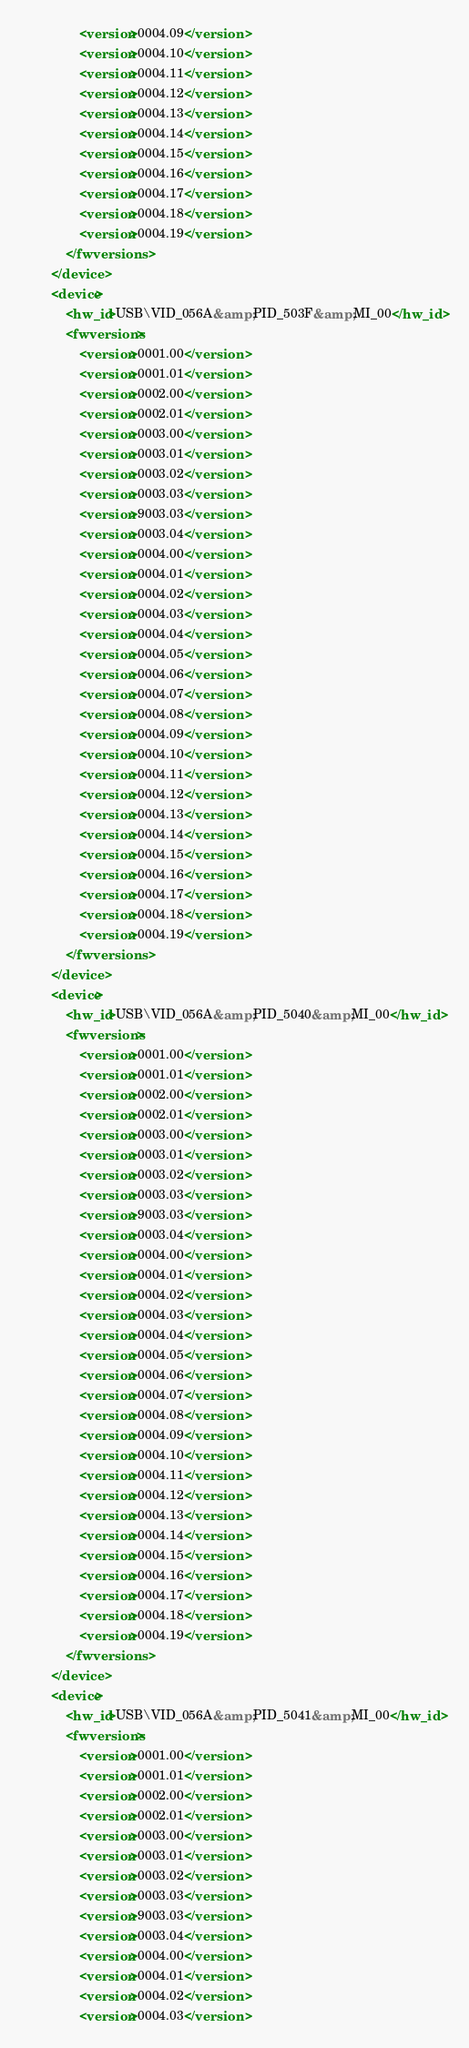<code> <loc_0><loc_0><loc_500><loc_500><_XML_>				<version>0004.09</version>
				<version>0004.10</version>
				<version>0004.11</version>
				<version>0004.12</version>
				<version>0004.13</version>
				<version>0004.14</version>
				<version>0004.15</version>
				<version>0004.16</version>
				<version>0004.17</version>
				<version>0004.18</version>
				<version>0004.19</version>
			</fwversions>
		</device>
		<device>
			<hw_id>USB\VID_056A&amp;PID_503F&amp;MI_00</hw_id>
			<fwversions>
				<version>0001.00</version>
				<version>0001.01</version>
				<version>0002.00</version>
				<version>0002.01</version>
				<version>0003.00</version>
				<version>0003.01</version>
				<version>0003.02</version>
				<version>0003.03</version>
				<version>9003.03</version>
				<version>0003.04</version>
				<version>0004.00</version>
				<version>0004.01</version>
				<version>0004.02</version>
				<version>0004.03</version>
				<version>0004.04</version>
				<version>0004.05</version>
				<version>0004.06</version>
				<version>0004.07</version>
				<version>0004.08</version>
				<version>0004.09</version>
				<version>0004.10</version>
				<version>0004.11</version>
				<version>0004.12</version>
				<version>0004.13</version>
				<version>0004.14</version>
				<version>0004.15</version>
				<version>0004.16</version>
				<version>0004.17</version>
				<version>0004.18</version>
				<version>0004.19</version>
			</fwversions>
		</device>
		<device>
			<hw_id>USB\VID_056A&amp;PID_5040&amp;MI_00</hw_id>
			<fwversions>
				<version>0001.00</version>
				<version>0001.01</version>
				<version>0002.00</version>
				<version>0002.01</version>
				<version>0003.00</version>
				<version>0003.01</version>
				<version>0003.02</version>
				<version>0003.03</version>
				<version>9003.03</version>
				<version>0003.04</version>
				<version>0004.00</version>
				<version>0004.01</version>
				<version>0004.02</version>
				<version>0004.03</version>
				<version>0004.04</version>
				<version>0004.05</version>
				<version>0004.06</version>
				<version>0004.07</version>
				<version>0004.08</version>
				<version>0004.09</version>
				<version>0004.10</version>
				<version>0004.11</version>
				<version>0004.12</version>
				<version>0004.13</version>
				<version>0004.14</version>
				<version>0004.15</version>
				<version>0004.16</version>
				<version>0004.17</version>
				<version>0004.18</version>
				<version>0004.19</version>
			</fwversions>
		</device>
		<device>
			<hw_id>USB\VID_056A&amp;PID_5041&amp;MI_00</hw_id>
			<fwversions>
				<version>0001.00</version>
				<version>0001.01</version>
				<version>0002.00</version>
				<version>0002.01</version>
				<version>0003.00</version>
				<version>0003.01</version>
				<version>0003.02</version>
				<version>0003.03</version>
				<version>9003.03</version>
				<version>0003.04</version>
				<version>0004.00</version>
				<version>0004.01</version>
				<version>0004.02</version>
				<version>0004.03</version></code> 